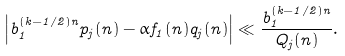<formula> <loc_0><loc_0><loc_500><loc_500>\left | b _ { 1 } ^ { ( k - 1 / 2 ) n } p _ { j } ( n ) - \alpha f _ { 1 } ( n ) q _ { j } ( n ) \right | \ll \frac { b _ { 1 } ^ { ( k - 1 / 2 ) n } } { Q _ { j } ( n ) } .</formula> 